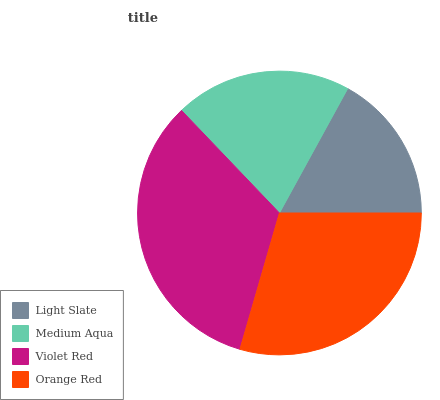Is Light Slate the minimum?
Answer yes or no. Yes. Is Violet Red the maximum?
Answer yes or no. Yes. Is Medium Aqua the minimum?
Answer yes or no. No. Is Medium Aqua the maximum?
Answer yes or no. No. Is Medium Aqua greater than Light Slate?
Answer yes or no. Yes. Is Light Slate less than Medium Aqua?
Answer yes or no. Yes. Is Light Slate greater than Medium Aqua?
Answer yes or no. No. Is Medium Aqua less than Light Slate?
Answer yes or no. No. Is Orange Red the high median?
Answer yes or no. Yes. Is Medium Aqua the low median?
Answer yes or no. Yes. Is Light Slate the high median?
Answer yes or no. No. Is Light Slate the low median?
Answer yes or no. No. 